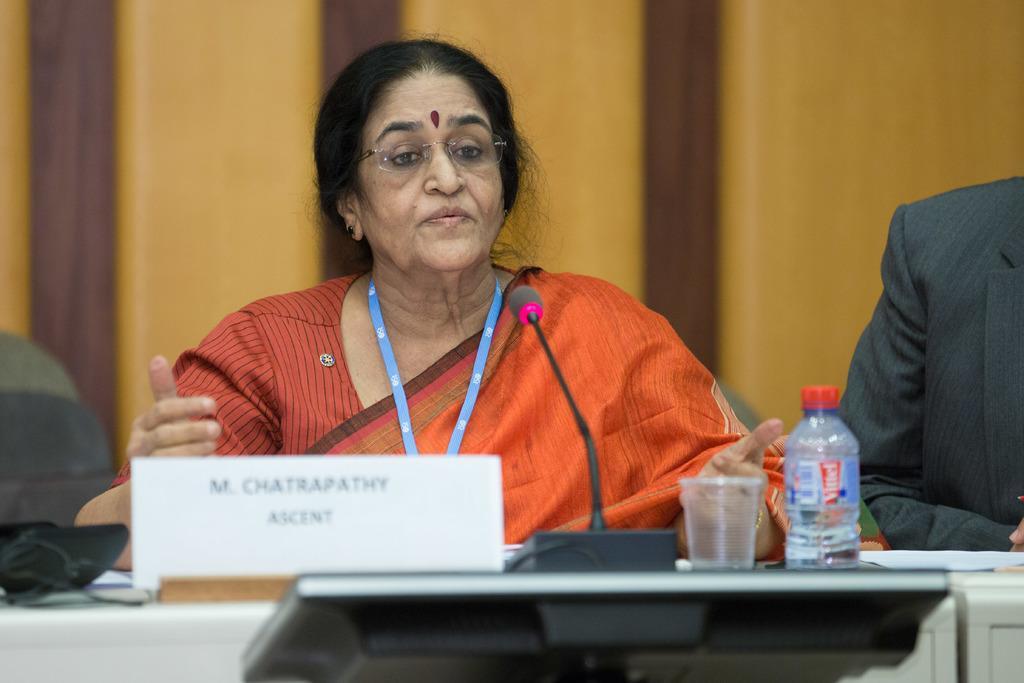How would you summarize this image in a sentence or two? In this picture we can see a woman. She is talking on the mike and she has spectacles. This is table. On the table there is a bottle and a glass. 